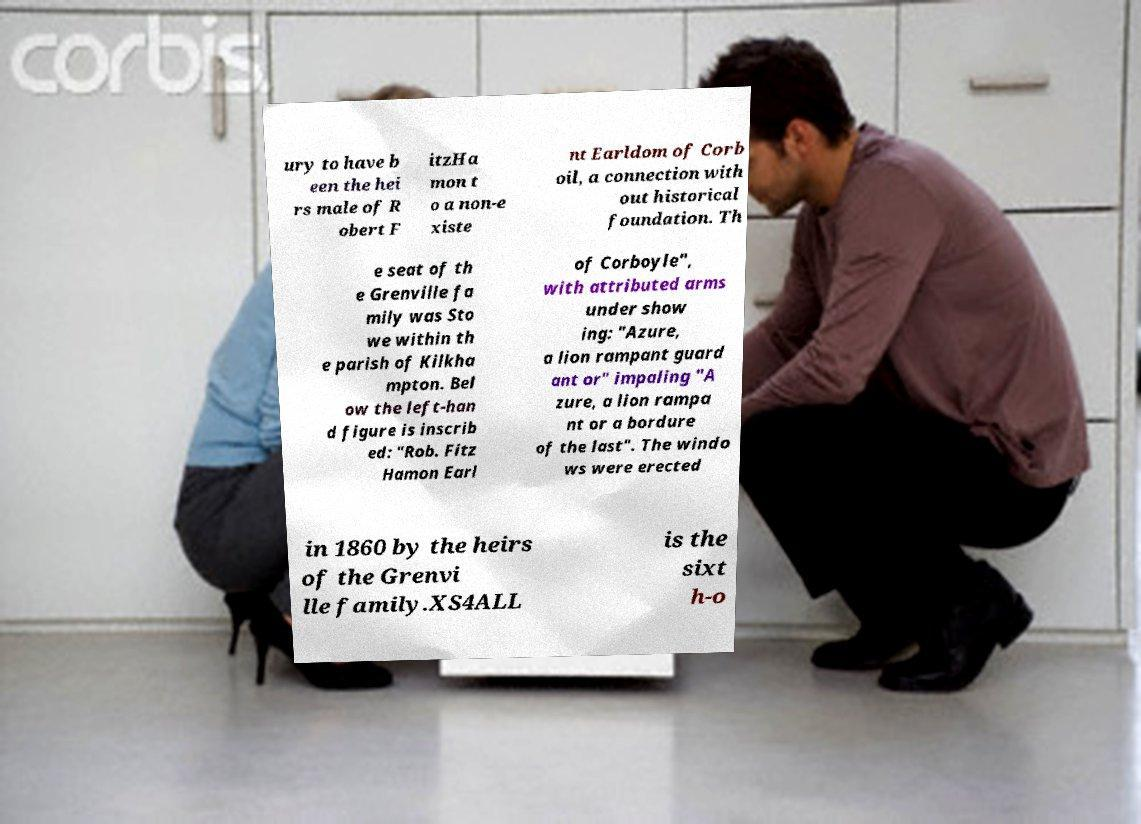Could you extract and type out the text from this image? ury to have b een the hei rs male of R obert F itzHa mon t o a non-e xiste nt Earldom of Corb oil, a connection with out historical foundation. Th e seat of th e Grenville fa mily was Sto we within th e parish of Kilkha mpton. Bel ow the left-han d figure is inscrib ed: "Rob. Fitz Hamon Earl of Corboyle", with attributed arms under show ing: "Azure, a lion rampant guard ant or" impaling "A zure, a lion rampa nt or a bordure of the last". The windo ws were erected in 1860 by the heirs of the Grenvi lle family.XS4ALL is the sixt h-o 